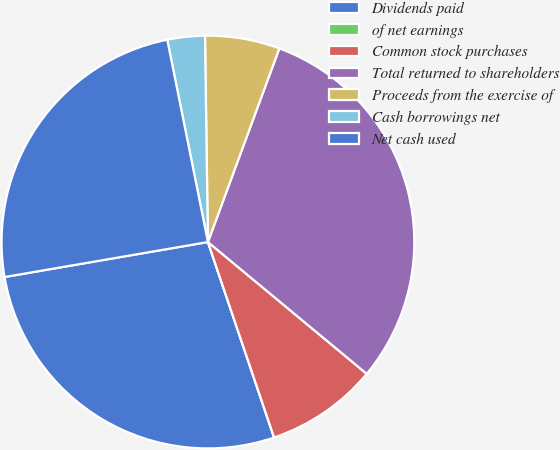Convert chart. <chart><loc_0><loc_0><loc_500><loc_500><pie_chart><fcel>Dividends paid<fcel>of net earnings<fcel>Common stock purchases<fcel>Total returned to shareholders<fcel>Proceeds from the exercise of<fcel>Cash borrowings net<fcel>Net cash used<nl><fcel>27.48%<fcel>0.0%<fcel>8.78%<fcel>30.4%<fcel>5.85%<fcel>2.93%<fcel>24.55%<nl></chart> 